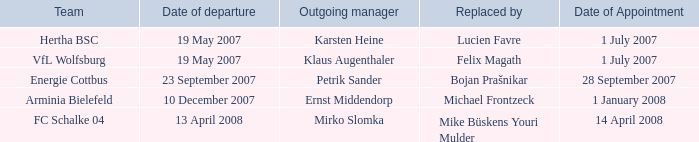When was the appointment date for the manager replaced by Lucien Favre? 1 July 2007. 